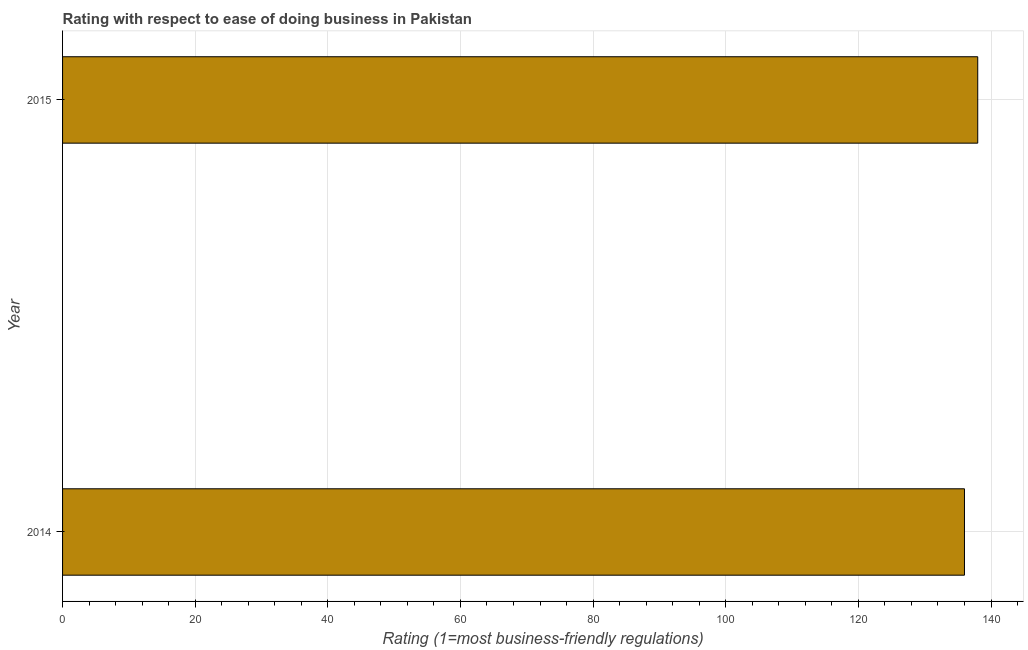Does the graph contain any zero values?
Provide a short and direct response. No. What is the title of the graph?
Keep it short and to the point. Rating with respect to ease of doing business in Pakistan. What is the label or title of the X-axis?
Make the answer very short. Rating (1=most business-friendly regulations). What is the label or title of the Y-axis?
Ensure brevity in your answer.  Year. What is the ease of doing business index in 2015?
Your response must be concise. 138. Across all years, what is the maximum ease of doing business index?
Your answer should be compact. 138. Across all years, what is the minimum ease of doing business index?
Provide a short and direct response. 136. In which year was the ease of doing business index maximum?
Offer a terse response. 2015. In which year was the ease of doing business index minimum?
Ensure brevity in your answer.  2014. What is the sum of the ease of doing business index?
Your answer should be compact. 274. What is the difference between the ease of doing business index in 2014 and 2015?
Provide a short and direct response. -2. What is the average ease of doing business index per year?
Offer a terse response. 137. What is the median ease of doing business index?
Your response must be concise. 137. What is the ratio of the ease of doing business index in 2014 to that in 2015?
Provide a succinct answer. 0.99. Is the ease of doing business index in 2014 less than that in 2015?
Offer a very short reply. Yes. In how many years, is the ease of doing business index greater than the average ease of doing business index taken over all years?
Your response must be concise. 1. How many years are there in the graph?
Offer a very short reply. 2. What is the Rating (1=most business-friendly regulations) of 2014?
Your answer should be compact. 136. What is the Rating (1=most business-friendly regulations) in 2015?
Give a very brief answer. 138. What is the difference between the Rating (1=most business-friendly regulations) in 2014 and 2015?
Your answer should be very brief. -2. What is the ratio of the Rating (1=most business-friendly regulations) in 2014 to that in 2015?
Make the answer very short. 0.99. 